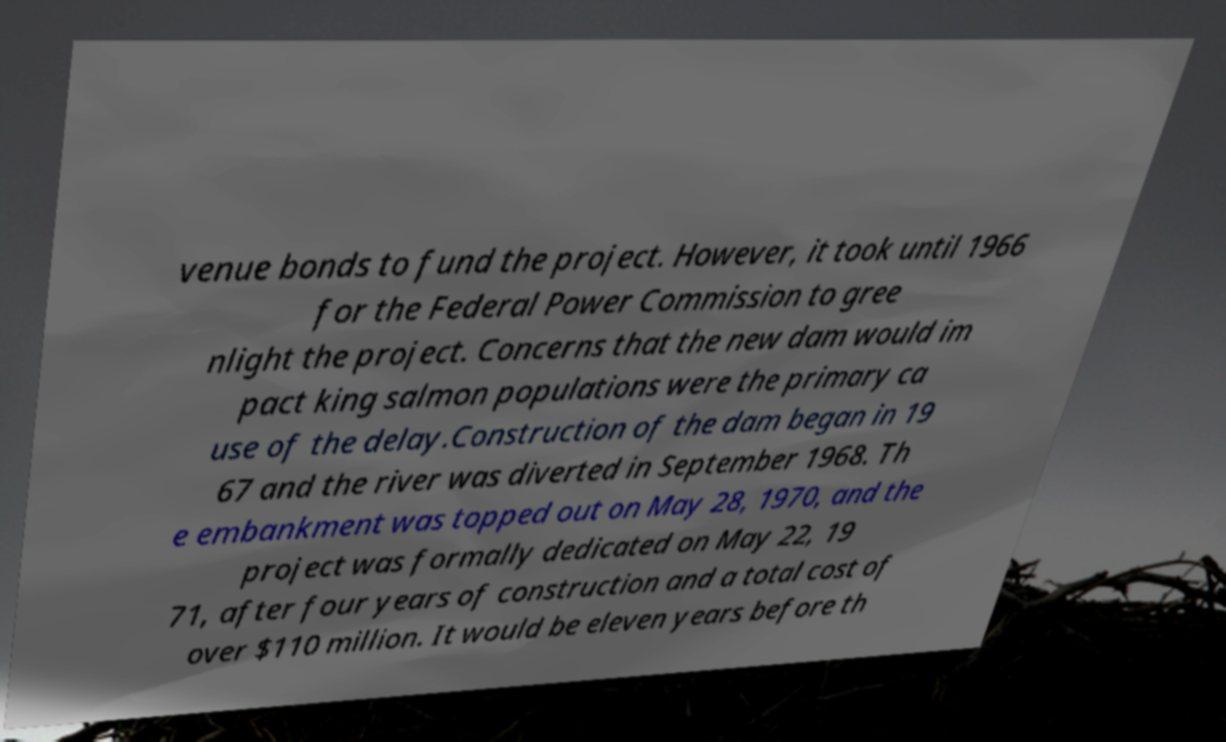What messages or text are displayed in this image? I need them in a readable, typed format. venue bonds to fund the project. However, it took until 1966 for the Federal Power Commission to gree nlight the project. Concerns that the new dam would im pact king salmon populations were the primary ca use of the delay.Construction of the dam began in 19 67 and the river was diverted in September 1968. Th e embankment was topped out on May 28, 1970, and the project was formally dedicated on May 22, 19 71, after four years of construction and a total cost of over $110 million. It would be eleven years before th 